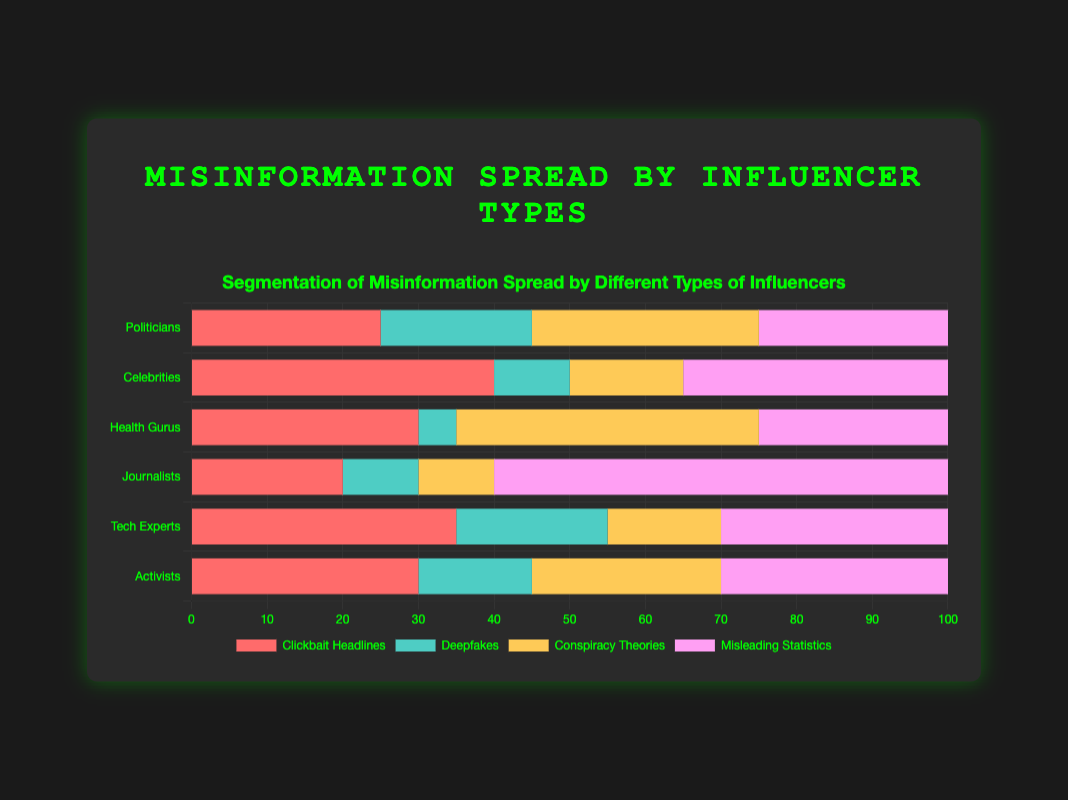Which influencer category spreads the most conspiracy theories? To determine the influencer category spreading the most conspiracy theories, observe the lengths of the yellow bars representing "Conspiracy Theories." Health Gurus have the longest yellow bar with 40%.
Answer: Health Gurus Which type of misinformation do journalists spread the most? Look at the segments for Journalists. The longest segment is pink, representing "Misleading Statistics," which is 60%.
Answer: Misleading Statistics Compare the proportion of clickbait headlines spread by politicians and celebrities. Which group spreads more? Compare the red bars for "Clickbait Headlines" between Politicians and Celebrities. Politicians have 25% while Celebrities have 40%.
Answer: Celebrities What is the combined total percentage of deepfakes spread by activists and tech experts? Add the percentages of "Deepfakes" for Activists (15%) and Tech Experts (20%). 15 + 20 = 35%.
Answer: 35% Which category has a higher percentage of misleading statistics: politicians or celebrities? Compare the pink bars for "Misleading Statistics" between Politicians and Celebrities. Politicians have 25% while Celebrities have 35%.
Answer: Celebrities What's the average percentage of clickbait headlines across all influencer categories? Sum the percentages for "Clickbait Headlines" for all categories and divide by the number of categories: (25 + 40 + 30 + 20 + 35 + 30) / 6 = 30%.
Answer: 30% Identify the influencer category with the least involvement in deepfakes. Compare the segments for "Deepfakes" (green bars) across all categories. Health Gurus have the lowest value with 5%.
Answer: Health Gurus If we combine the percentage of conspiracy theories spread by activists and tech experts, do they exceed the percentage spread by health gurus? Sum of conspiracy theories for Activists (25%) and Tech Experts (15%) is 40%. Health Gurus have 40%, so they are equal.
Answer: No Which two influencer categories spread misleading statistics at the same rate, and what is that rate? Compare the pink bars for "Misleading Statistics." Both Activists and Tech Experts have 30%.
Answer: Activists and Tech Experts, 30% Do politicians or journalists have a higher total percentage of misinformation spread? Sum up all segments for both categories. Politicians: (25 + 20 + 30 + 25) = 100%. Journalists: (20 + 10 + 10 + 60) = 100%. Both have the same total percentage.
Answer: Equal 